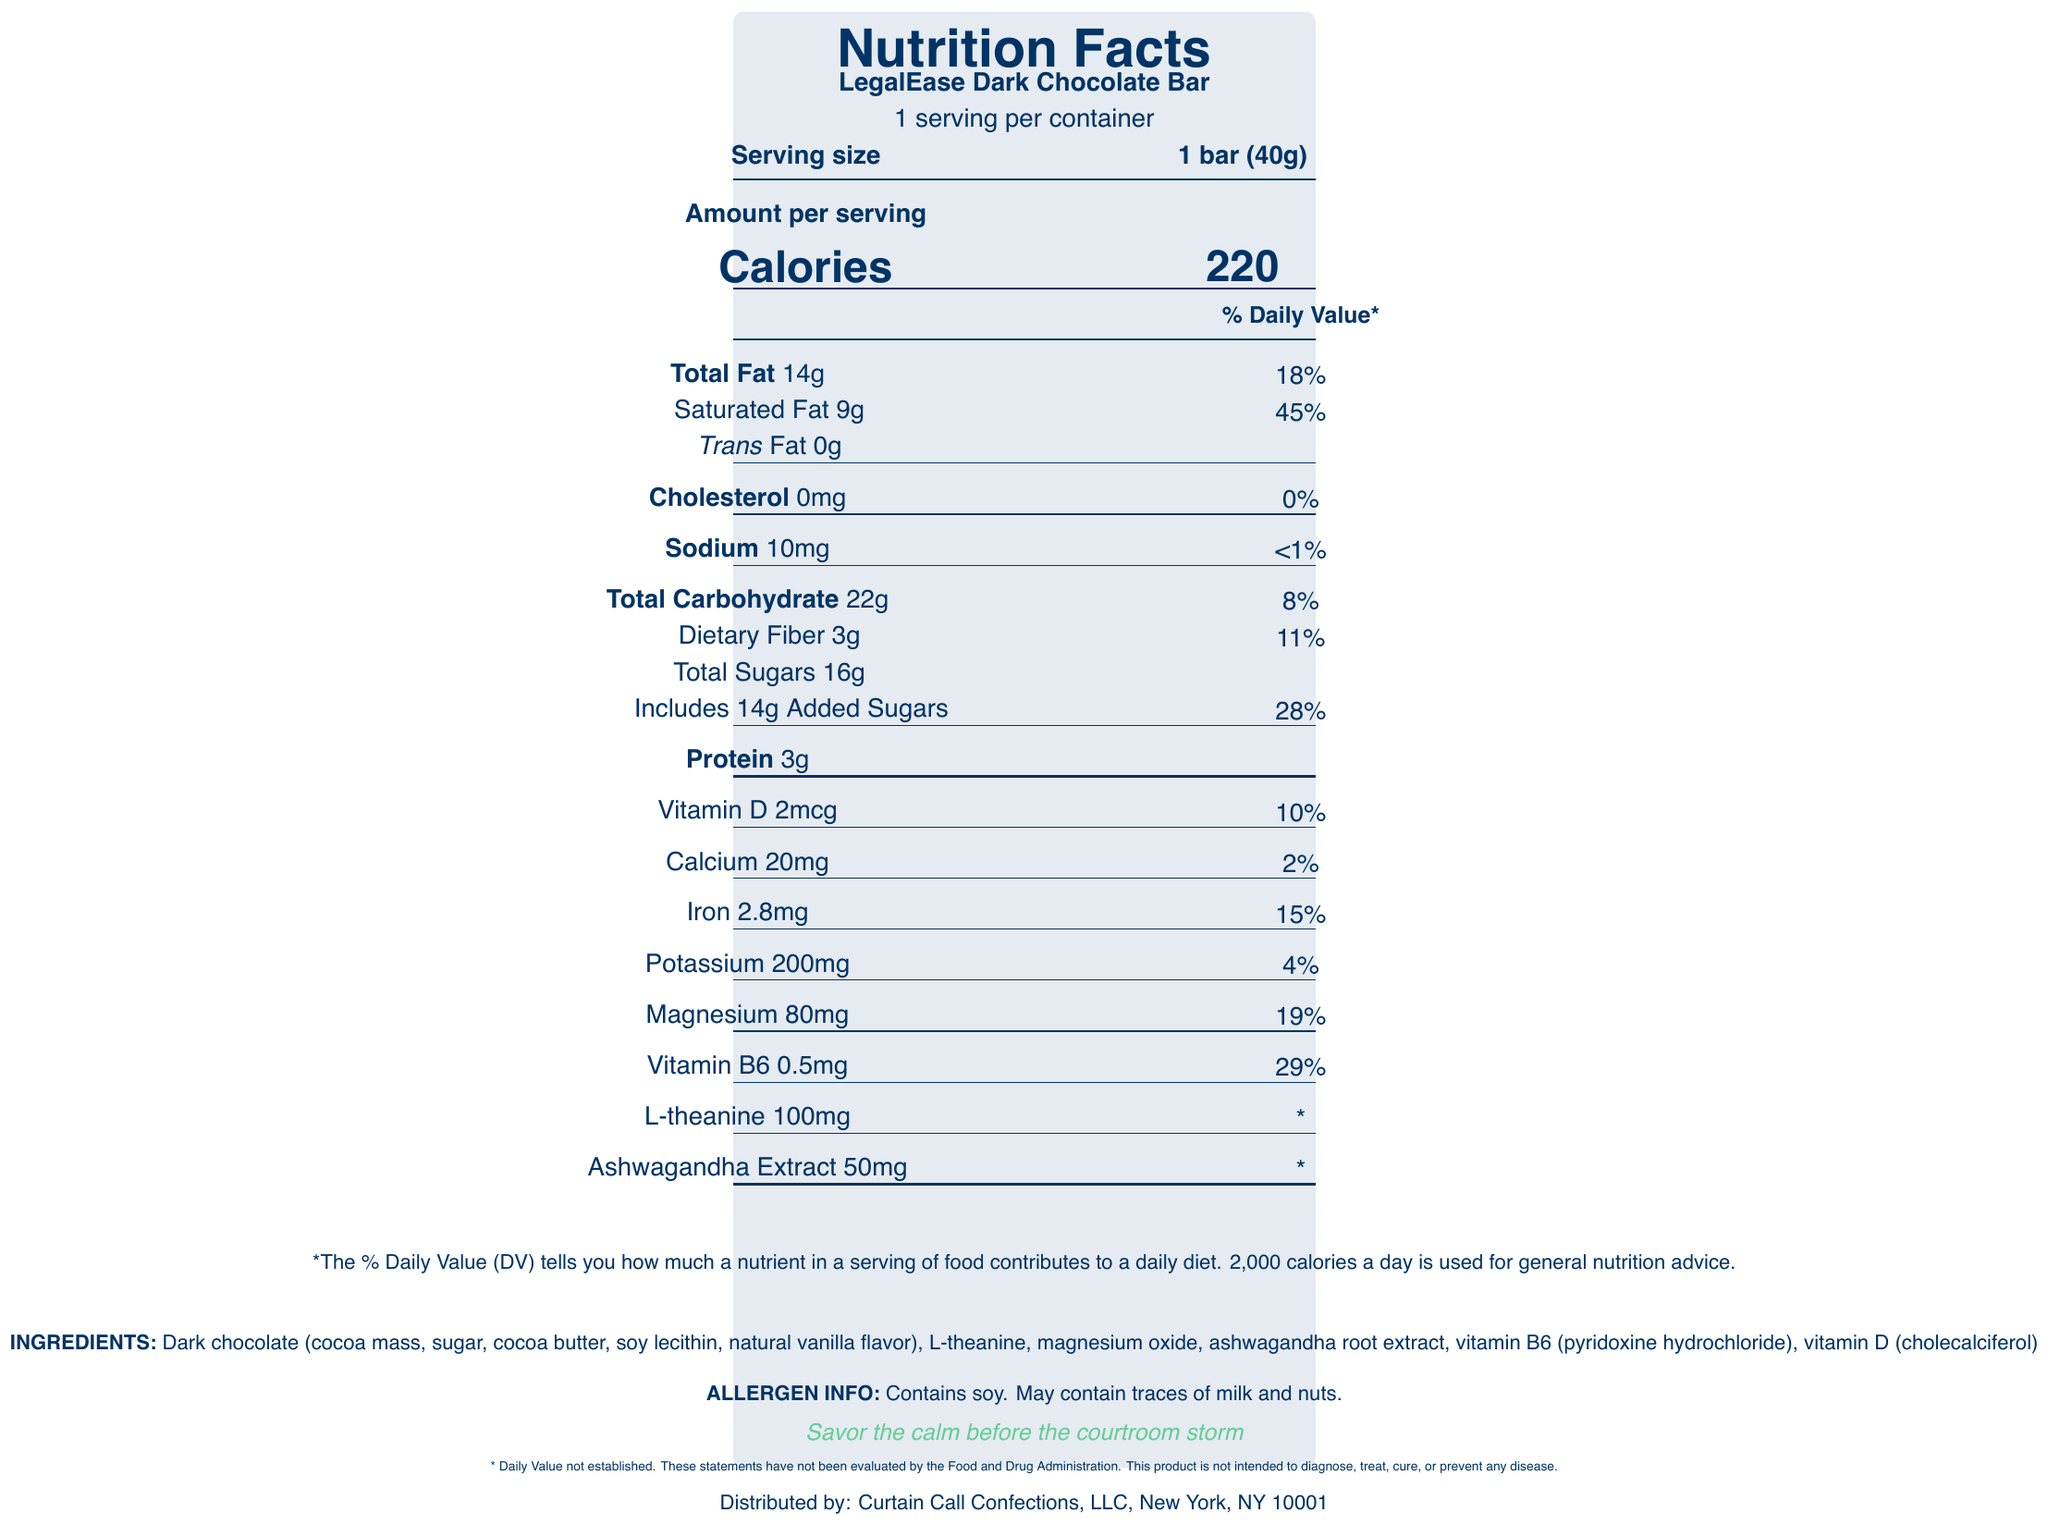what is the name of the product? The product name is stated at the top under "Nutrition Facts".
Answer: LegalEase Dark Chocolate Bar what is the serving size? The serving size is listed right next to "Serving size" in the document.
Answer: 1 bar (40g) how many calories are there in one serving of this chocolate bar? The number of calories per serving is mentioned prominently in large font under "Calories".
Answer: 220 what percentage of the daily value for saturated fat does one serving provide? The daily value percentage for saturated fat is listed beside "Saturated Fat 9g".
Answer: 45% what are the main ingredients in the LegalEase Dark Chocolate Bar? The ingredients are listed near the bottom under "INGREDIENTS".
Answer: Dark chocolate, L-theanine, magnesium oxide, ashwagandha root extract, vitamin B6, vitamin D what is the sodium content per serving? The sodium content per serving is listed as "Sodium 10mg".
Answer: 10mg what percentage of the daily value for dietary fiber does one serving provide? The daily value percentage for dietary fiber is listed beside "Dietary Fiber 3g".
Answer: 11% what special nutrients are included in the LegalEase Dark Chocolate Bar to help with stress relief? A. Vitamin C and Zinc B. Ashwagandha Extract and L-Theanine C. Ginseng and Magnesium D. Melatonin and Iron The document lists Ashwagandha Extract and L-Theanine as special nutrients for stress relief.
Answer: B which company distributes the LegalEase Dark Chocolate Bar? A. Health Nut Inc. B. Nutrition Masters LLC C. Curtain Call Confections, LLC D. Sweet Treats Ltd. The company distributing the product is mentioned at the bottom as "Distributed by: Curtain Call Confections, LLC".
Answer: C does the LegalEase Dark Chocolate Bar contain any trans fat? The document states "Trans Fat 0g".
Answer: No is the LegalEase Dark Chocolate Bar suitable for someone with a soy allergy? The allergen information states that the product contains soy.
Answer: No please summarize the main idea of the document. The document presents comprehensive nutritional information, listing vitamins, minerals, ingredients, and special stress-relieving substances in the product. It also provides information about allergens and the distributing company.
Answer: The document is the Nutrition Facts Label for the LegalEase Dark Chocolate Bar, which is fortified with vitamins and stress-relieving substances like L-theanine and ashwagandha extract. It provides detailed nutritional information, ingredient list, and allergen info for one 40g bar serving. who approves the health claims made in the document? The document mentions that the statements have not been evaluated by the Food and Drug Administration, but does not state who, if anyone, approves the health claims.
Answer: Not enough information 